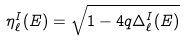Convert formula to latex. <formula><loc_0><loc_0><loc_500><loc_500>\eta ^ { I } _ { \ell } ( E ) = \sqrt { 1 - 4 q \Delta ^ { I } _ { \ell } ( E ) }</formula> 